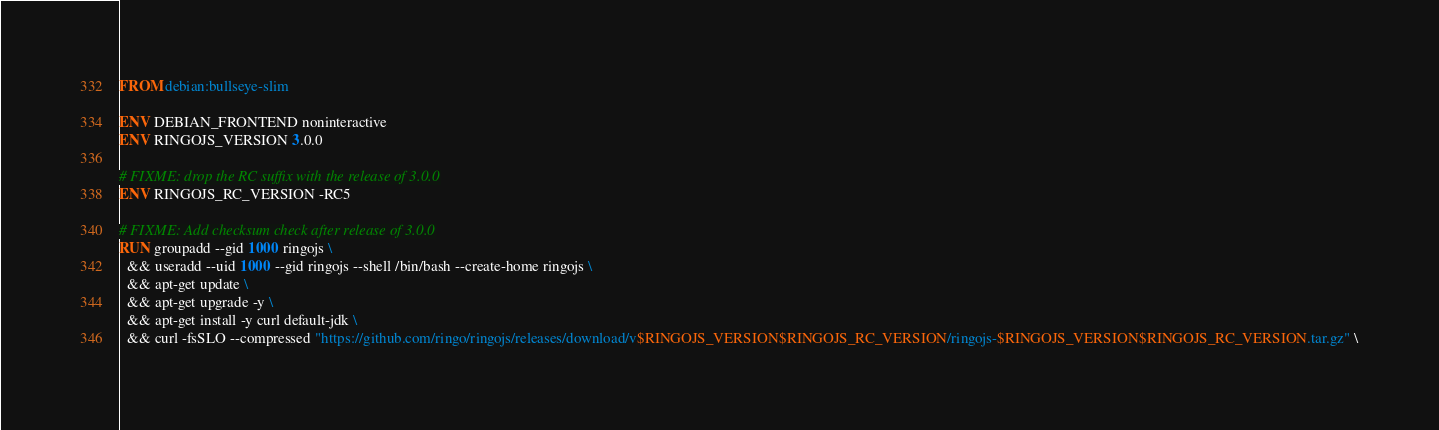<code> <loc_0><loc_0><loc_500><loc_500><_Dockerfile_>FROM debian:bullseye-slim

ENV DEBIAN_FRONTEND noninteractive
ENV RINGOJS_VERSION 3.0.0

# FIXME: drop the RC suffix with the release of 3.0.0
ENV RINGOJS_RC_VERSION -RC5

# FIXME: Add checksum check after release of 3.0.0
RUN groupadd --gid 1000 ringojs \
  && useradd --uid 1000 --gid ringojs --shell /bin/bash --create-home ringojs \
  && apt-get update \
  && apt-get upgrade -y \
  && apt-get install -y curl default-jdk \
  && curl -fsSLO --compressed "https://github.com/ringo/ringojs/releases/download/v$RINGOJS_VERSION$RINGOJS_RC_VERSION/ringojs-$RINGOJS_VERSION$RINGOJS_RC_VERSION.tar.gz" \</code> 